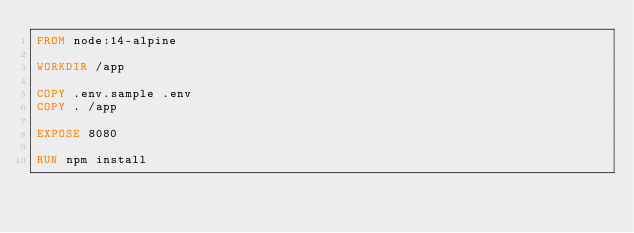Convert code to text. <code><loc_0><loc_0><loc_500><loc_500><_Dockerfile_>FROM node:14-alpine

WORKDIR /app 

COPY .env.sample .env
COPY . /app 

EXPOSE 8080

RUN npm install
</code> 